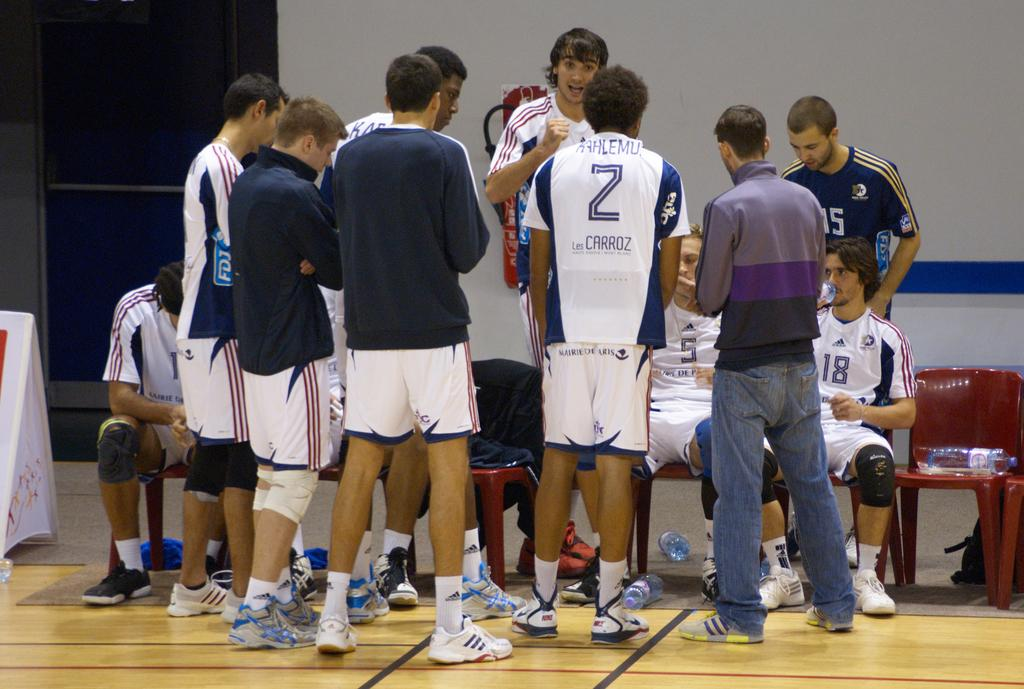<image>
Write a terse but informative summary of the picture. some young men sports players hanging out together, one player has a 2 on his shirt with KAHLEMU Les Carroz. 